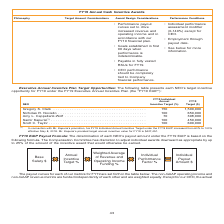According to Nortonlifelock's financial document, What does the table present? each NEO’s target incentive opportunity for FY19 under the FY19 Executive Annual Incentive Plan. The document states: "arget Opportunities: The following table presents each NEO’s target incentive opportunity for FY19 under the FY19 Executive Annual Incentive Plan (the..." Also, What is Mr Kapuria's prorated target annual incentive value for FY19? According to the financial document, $427,451. The relevant text states: "prorated target annual incentive value for FY19 is $427,451...." Also, What is  Gregory S. Clark's FY19 incentive target(%)?  According to the financial document, 150 (percentage). The relevant text states: "Gregory S. Clark . 150 1,500,000 Nicholas R. Noviello . 100 650,000 Amy L. Cappellanti-Wolf . 70 308,000 Samir Kapuria (1)..." Also, can you calculate: What is the total FY19 target($) for all NEOs? Based on the calculation:  1,500,000+650,000+308,000+450,000+600,000, the result is 3508000. This is based on the information: "Gregory S. Clark . 150 1,500,000 Nicholas R. Noviello . 100 650,000 Amy L. Cappellanti-Wolf . 70 308,000 Samir Kapuria (1) . 100 450 viello . 100 650,000 Amy L. Cappellanti-Wolf . 70 308,000 Samir Kap..." The key data points involved are: 1,500,000, 308,000, 450,000. Also, can you calculate: What is the average FY19 target ($) for NEOs? To answer this question, I need to perform calculations using the financial data. The calculation is: (1,500,000+650,000+308,000+450,000+600,000)/5, which equals 701600. This is based on the information: "Gregory S. Clark . 150 1,500,000 Nicholas R. Noviello . 100 650,000 Amy L. Cappellanti-Wolf . 70 308,000 Samir Kapuria (1) . 100 450 viello . 100 650,000 Amy L. Cappellanti-Wolf . 70 308,000 Samir Kap..." The key data points involved are: 1,500,000, 308,000, 450,000. Additionally, Who are the NEO(s) with a FY19 target above the average? According to the financial document, Gregory S. Clark. The relevant text states: "Gregory S. Clark . 150 1,500,000 Nicholas R. Noviello . 100 650,000 Amy L. Cappellanti-Wolf . 70 308,000 Samir Kapur..." 